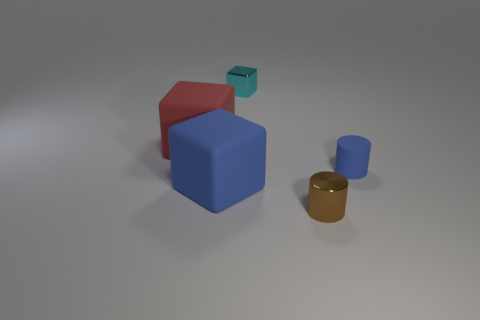Add 2 purple matte spheres. How many objects exist? 7 Subtract all large matte cubes. How many cubes are left? 1 Subtract 3 blocks. How many blocks are left? 0 Add 4 small cyan blocks. How many small cyan blocks are left? 5 Add 3 blue matte things. How many blue matte things exist? 5 Subtract all blue cubes. How many cubes are left? 2 Subtract 0 purple cylinders. How many objects are left? 5 Subtract all cubes. How many objects are left? 2 Subtract all gray cubes. Subtract all purple spheres. How many cubes are left? 3 Subtract all yellow cylinders. How many red cubes are left? 1 